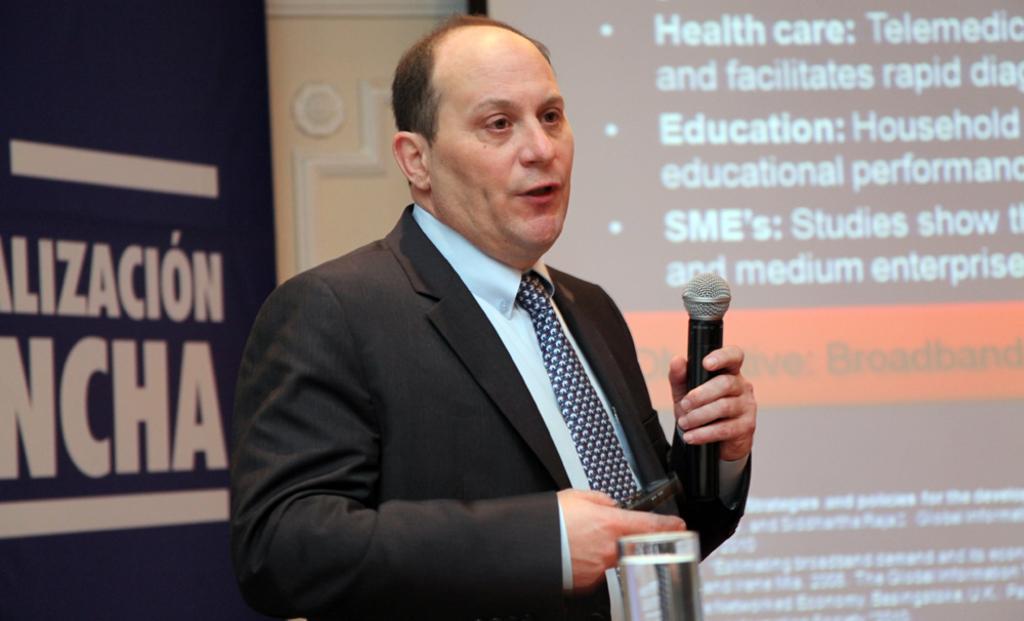In one or two sentences, can you explain what this image depicts? This picture shows a man standing and speaking with the help of a microphone and we see a projected screen on the right and a hoarding on the left and we see a water glass on the table 